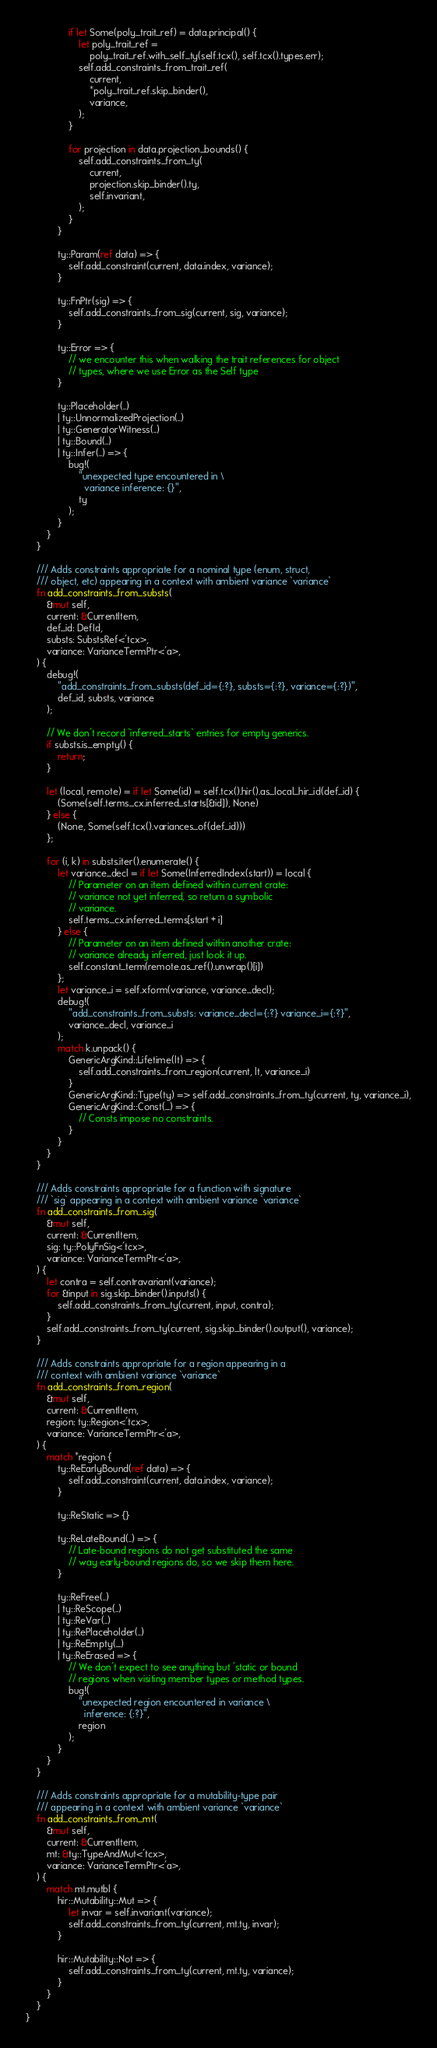Convert code to text. <code><loc_0><loc_0><loc_500><loc_500><_Rust_>                if let Some(poly_trait_ref) = data.principal() {
                    let poly_trait_ref =
                        poly_trait_ref.with_self_ty(self.tcx(), self.tcx().types.err);
                    self.add_constraints_from_trait_ref(
                        current,
                        *poly_trait_ref.skip_binder(),
                        variance,
                    );
                }

                for projection in data.projection_bounds() {
                    self.add_constraints_from_ty(
                        current,
                        projection.skip_binder().ty,
                        self.invariant,
                    );
                }
            }

            ty::Param(ref data) => {
                self.add_constraint(current, data.index, variance);
            }

            ty::FnPtr(sig) => {
                self.add_constraints_from_sig(current, sig, variance);
            }

            ty::Error => {
                // we encounter this when walking the trait references for object
                // types, where we use Error as the Self type
            }

            ty::Placeholder(..)
            | ty::UnnormalizedProjection(..)
            | ty::GeneratorWitness(..)
            | ty::Bound(..)
            | ty::Infer(..) => {
                bug!(
                    "unexpected type encountered in \
                      variance inference: {}",
                    ty
                );
            }
        }
    }

    /// Adds constraints appropriate for a nominal type (enum, struct,
    /// object, etc) appearing in a context with ambient variance `variance`
    fn add_constraints_from_substs(
        &mut self,
        current: &CurrentItem,
        def_id: DefId,
        substs: SubstsRef<'tcx>,
        variance: VarianceTermPtr<'a>,
    ) {
        debug!(
            "add_constraints_from_substs(def_id={:?}, substs={:?}, variance={:?})",
            def_id, substs, variance
        );

        // We don't record `inferred_starts` entries for empty generics.
        if substs.is_empty() {
            return;
        }

        let (local, remote) = if let Some(id) = self.tcx().hir().as_local_hir_id(def_id) {
            (Some(self.terms_cx.inferred_starts[&id]), None)
        } else {
            (None, Some(self.tcx().variances_of(def_id)))
        };

        for (i, k) in substs.iter().enumerate() {
            let variance_decl = if let Some(InferredIndex(start)) = local {
                // Parameter on an item defined within current crate:
                // variance not yet inferred, so return a symbolic
                // variance.
                self.terms_cx.inferred_terms[start + i]
            } else {
                // Parameter on an item defined within another crate:
                // variance already inferred, just look it up.
                self.constant_term(remote.as_ref().unwrap()[i])
            };
            let variance_i = self.xform(variance, variance_decl);
            debug!(
                "add_constraints_from_substs: variance_decl={:?} variance_i={:?}",
                variance_decl, variance_i
            );
            match k.unpack() {
                GenericArgKind::Lifetime(lt) => {
                    self.add_constraints_from_region(current, lt, variance_i)
                }
                GenericArgKind::Type(ty) => self.add_constraints_from_ty(current, ty, variance_i),
                GenericArgKind::Const(_) => {
                    // Consts impose no constraints.
                }
            }
        }
    }

    /// Adds constraints appropriate for a function with signature
    /// `sig` appearing in a context with ambient variance `variance`
    fn add_constraints_from_sig(
        &mut self,
        current: &CurrentItem,
        sig: ty::PolyFnSig<'tcx>,
        variance: VarianceTermPtr<'a>,
    ) {
        let contra = self.contravariant(variance);
        for &input in sig.skip_binder().inputs() {
            self.add_constraints_from_ty(current, input, contra);
        }
        self.add_constraints_from_ty(current, sig.skip_binder().output(), variance);
    }

    /// Adds constraints appropriate for a region appearing in a
    /// context with ambient variance `variance`
    fn add_constraints_from_region(
        &mut self,
        current: &CurrentItem,
        region: ty::Region<'tcx>,
        variance: VarianceTermPtr<'a>,
    ) {
        match *region {
            ty::ReEarlyBound(ref data) => {
                self.add_constraint(current, data.index, variance);
            }

            ty::ReStatic => {}

            ty::ReLateBound(..) => {
                // Late-bound regions do not get substituted the same
                // way early-bound regions do, so we skip them here.
            }

            ty::ReFree(..)
            | ty::ReScope(..)
            | ty::ReVar(..)
            | ty::RePlaceholder(..)
            | ty::ReEmpty(_)
            | ty::ReErased => {
                // We don't expect to see anything but 'static or bound
                // regions when visiting member types or method types.
                bug!(
                    "unexpected region encountered in variance \
                      inference: {:?}",
                    region
                );
            }
        }
    }

    /// Adds constraints appropriate for a mutability-type pair
    /// appearing in a context with ambient variance `variance`
    fn add_constraints_from_mt(
        &mut self,
        current: &CurrentItem,
        mt: &ty::TypeAndMut<'tcx>,
        variance: VarianceTermPtr<'a>,
    ) {
        match mt.mutbl {
            hir::Mutability::Mut => {
                let invar = self.invariant(variance);
                self.add_constraints_from_ty(current, mt.ty, invar);
            }

            hir::Mutability::Not => {
                self.add_constraints_from_ty(current, mt.ty, variance);
            }
        }
    }
}
</code> 